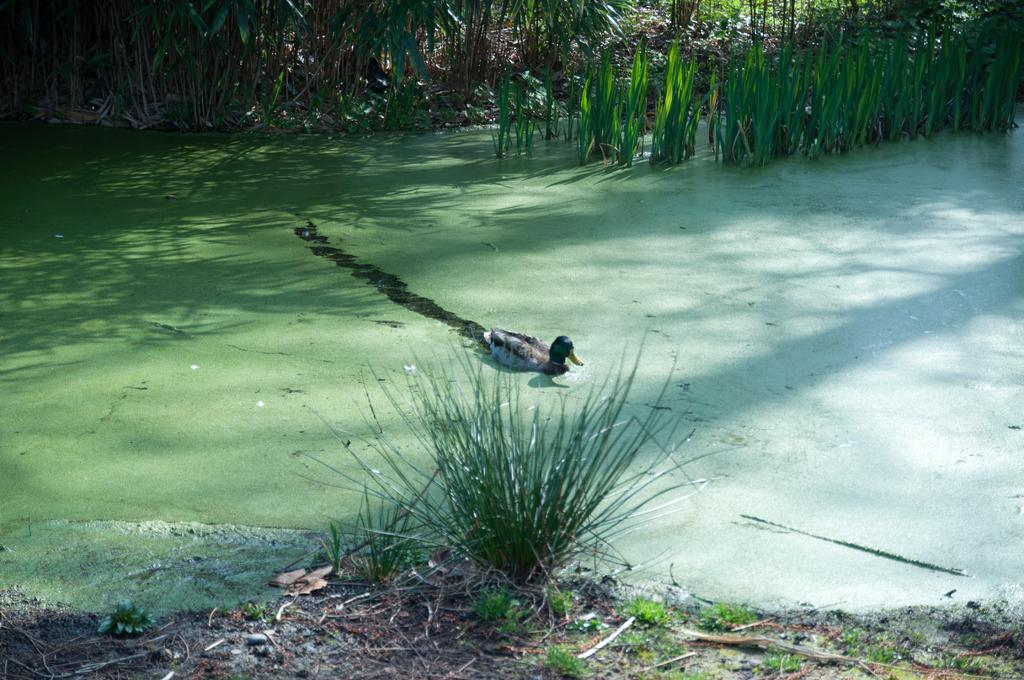What is the main subject of the image? There is a duck in the center of the image. Where is the duck located? The duck is on the water. What can be seen in the background of the image? There is grass visible in the background of the image. What type of wool can be seen on the duck's back in the image? There is no wool present on the duck's back in the image. How many ducks are visible in the image? There is only one duck visible in the image. Can you see a snail crawling on the grass in the background of the image? There is no snail present in the image. 